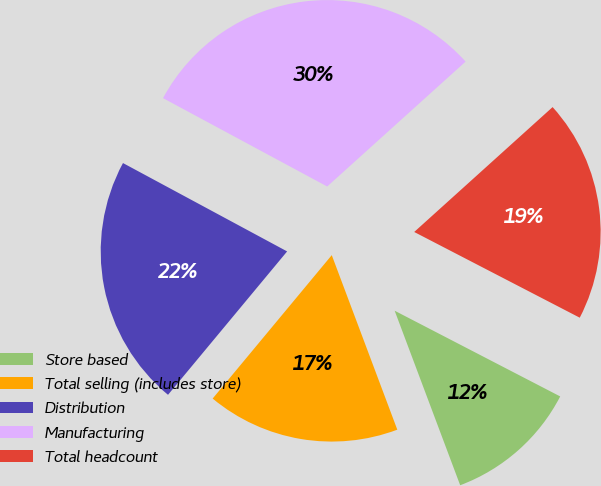Convert chart to OTSL. <chart><loc_0><loc_0><loc_500><loc_500><pie_chart><fcel>Store based<fcel>Total selling (includes store)<fcel>Distribution<fcel>Manufacturing<fcel>Total headcount<nl><fcel>11.68%<fcel>16.75%<fcel>21.83%<fcel>30.46%<fcel>19.29%<nl></chart> 